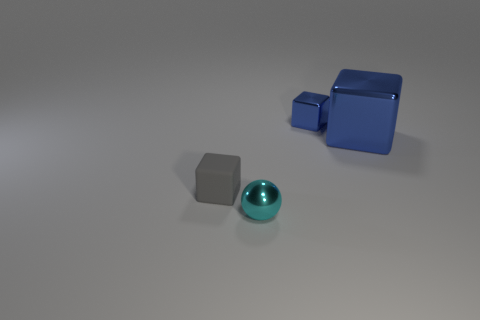Add 4 tiny cyan metallic balls. How many objects exist? 8 Subtract all spheres. How many objects are left? 3 Add 4 large cubes. How many large cubes are left? 5 Add 1 large metal cylinders. How many large metal cylinders exist? 1 Subtract 0 yellow spheres. How many objects are left? 4 Subtract all large things. Subtract all blue metal objects. How many objects are left? 1 